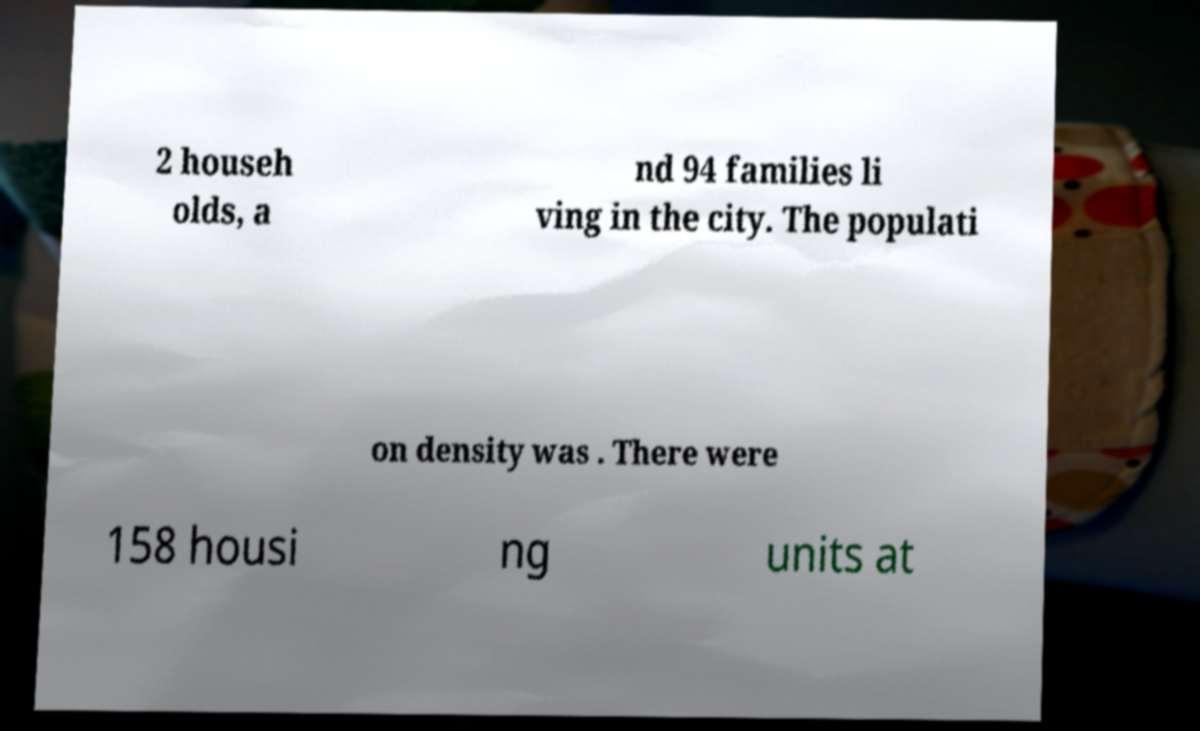There's text embedded in this image that I need extracted. Can you transcribe it verbatim? 2 househ olds, a nd 94 families li ving in the city. The populati on density was . There were 158 housi ng units at 